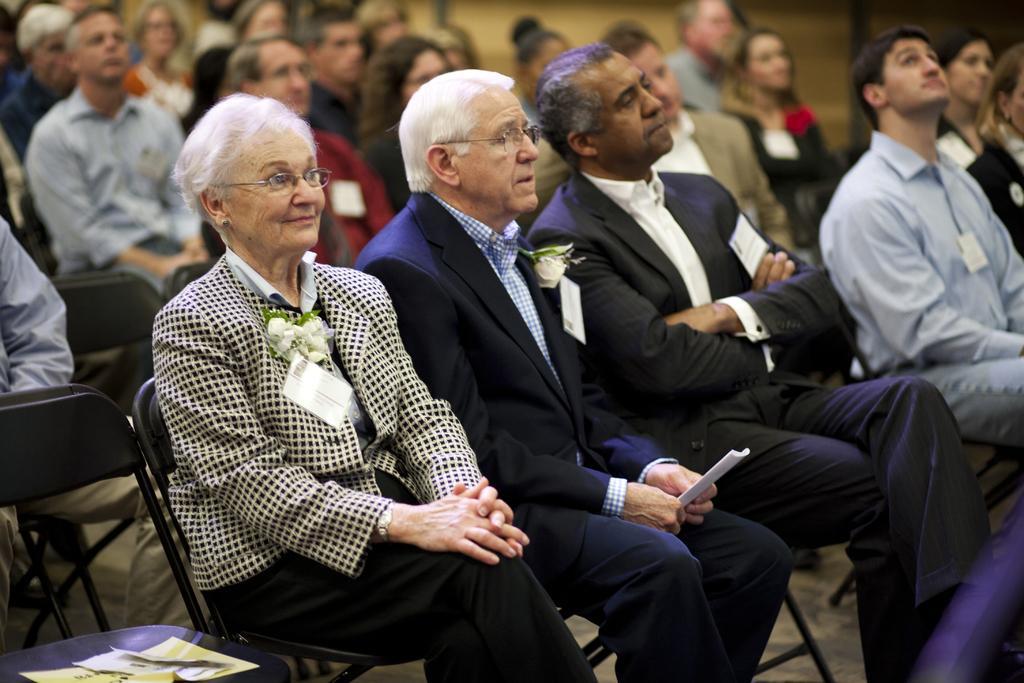Can you describe this image briefly? There are group of people sitting on the chairs. These look like papers placed on the chair. I can see the badges attached to the clothes. 